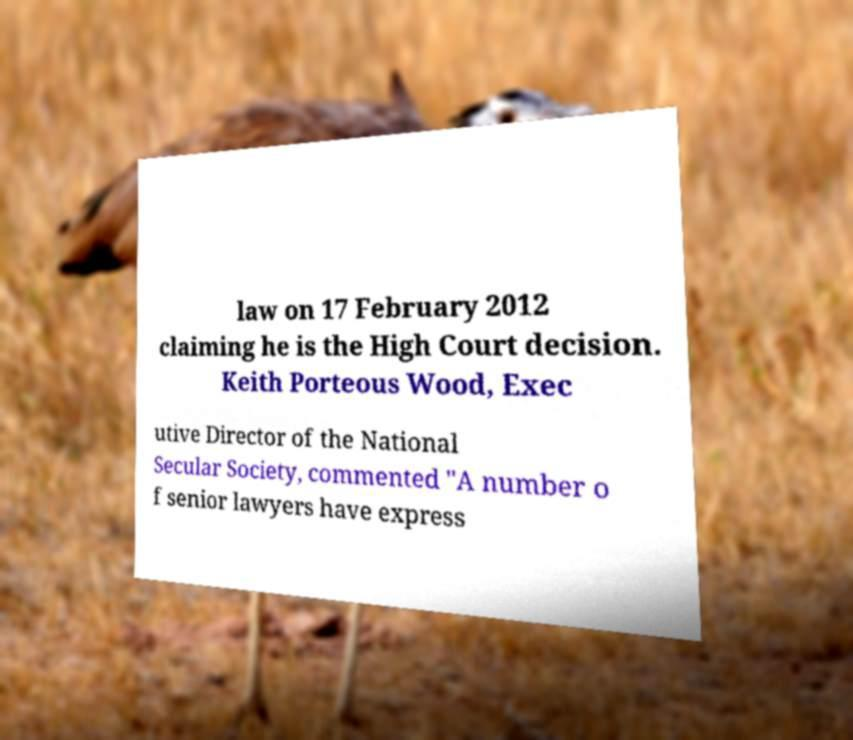Please identify and transcribe the text found in this image. law on 17 February 2012 claiming he is the High Court decision. Keith Porteous Wood, Exec utive Director of the National Secular Society, commented "A number o f senior lawyers have express 